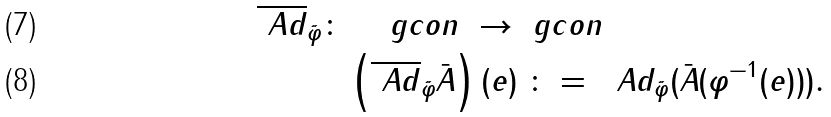<formula> <loc_0><loc_0><loc_500><loc_500>\overline { \ A d } _ { \tilde { \varphi } } \colon & \quad \ g c o n \ \rightarrow \ g c o n \\ & \left ( \overline { \ A d } _ { \tilde { \varphi } } { \bar { A } } \right ) ( e ) \ \colon = \ \ A d _ { \tilde { \varphi } } ( { \bar { A } } ( \varphi ^ { - 1 } ( e ) ) ) .</formula> 